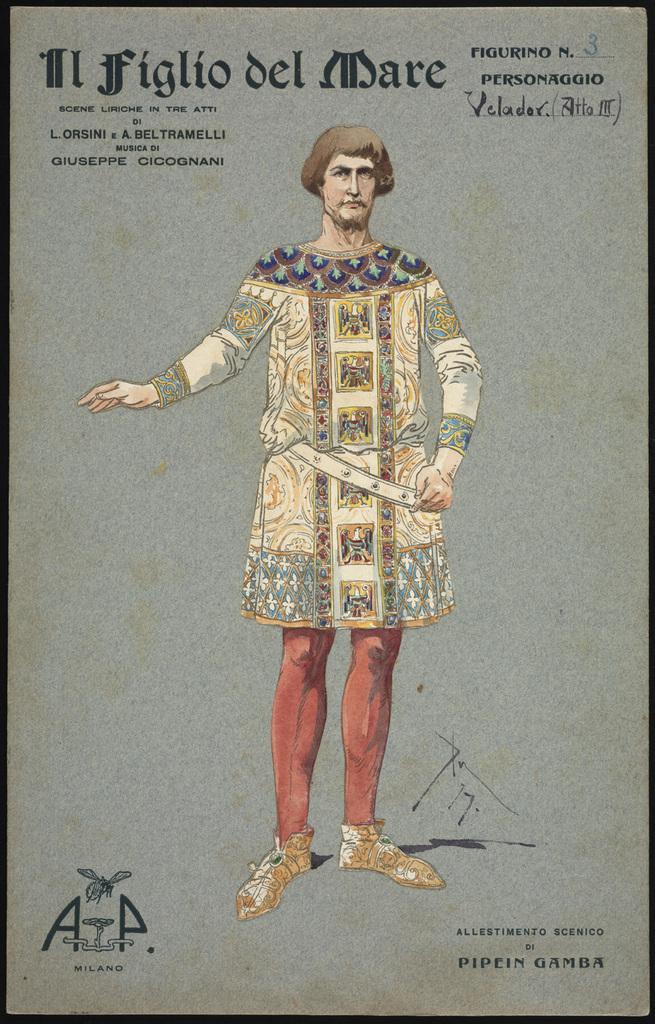Could you give a brief overview of what you see in this image? In this picture we can see a person. This is a painting. 